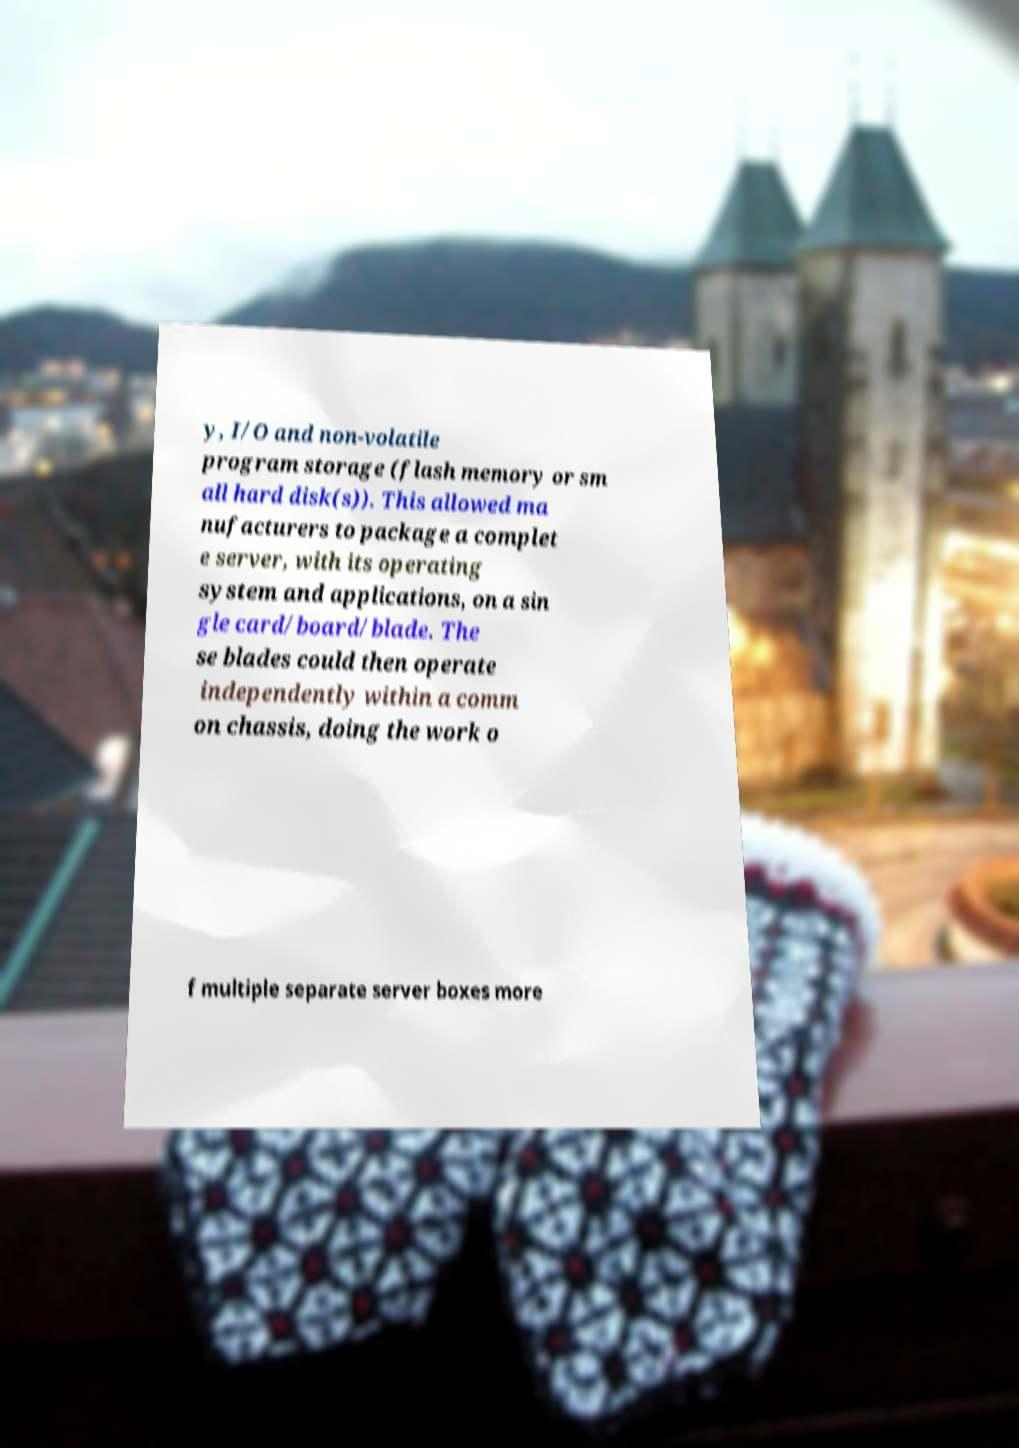I need the written content from this picture converted into text. Can you do that? y, I/O and non-volatile program storage (flash memory or sm all hard disk(s)). This allowed ma nufacturers to package a complet e server, with its operating system and applications, on a sin gle card/board/blade. The se blades could then operate independently within a comm on chassis, doing the work o f multiple separate server boxes more 